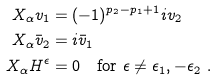Convert formula to latex. <formula><loc_0><loc_0><loc_500><loc_500>X _ { \alpha } v _ { 1 } & = ( - 1 ) ^ { p _ { 2 } - p _ { 1 } + 1 } i v _ { 2 } \\ X _ { \alpha } \bar { v } _ { 2 } & = i \bar { v } _ { 1 } \\ X _ { \alpha } H ^ { \epsilon } & = 0 \quad \text {for} \ \epsilon \neq \epsilon _ { 1 } , - \epsilon _ { 2 } \ .</formula> 